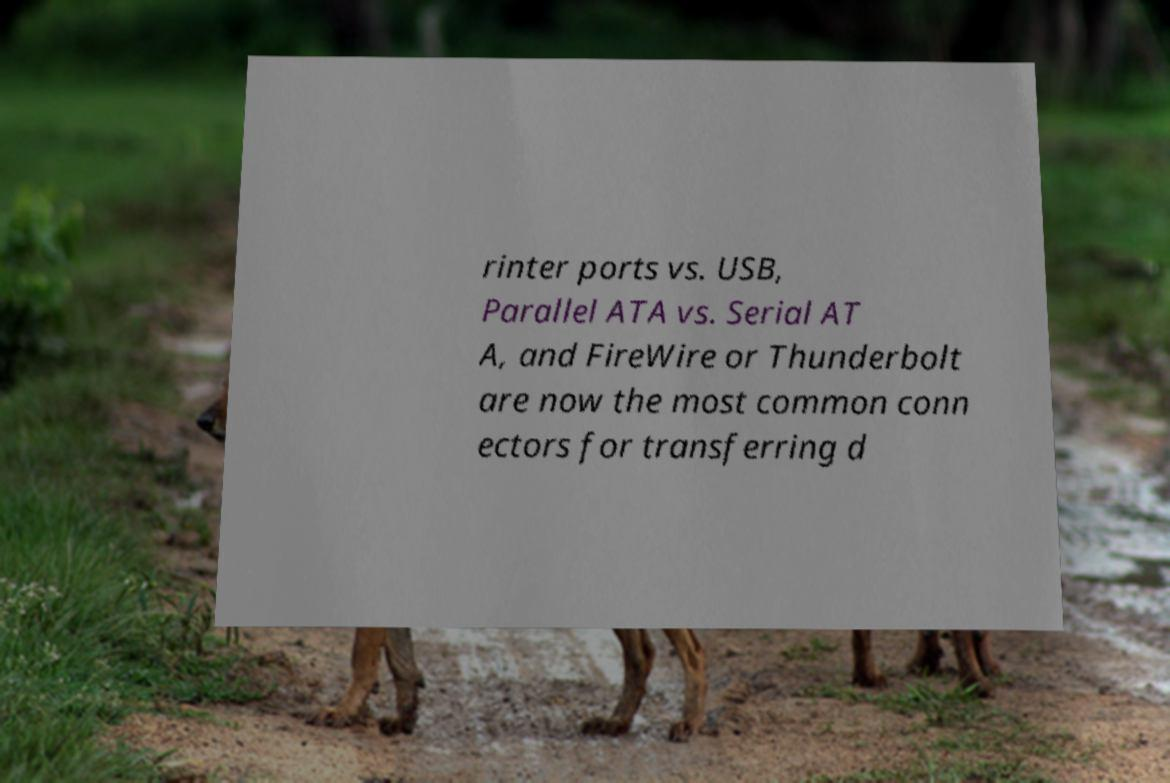For documentation purposes, I need the text within this image transcribed. Could you provide that? rinter ports vs. USB, Parallel ATA vs. Serial AT A, and FireWire or Thunderbolt are now the most common conn ectors for transferring d 